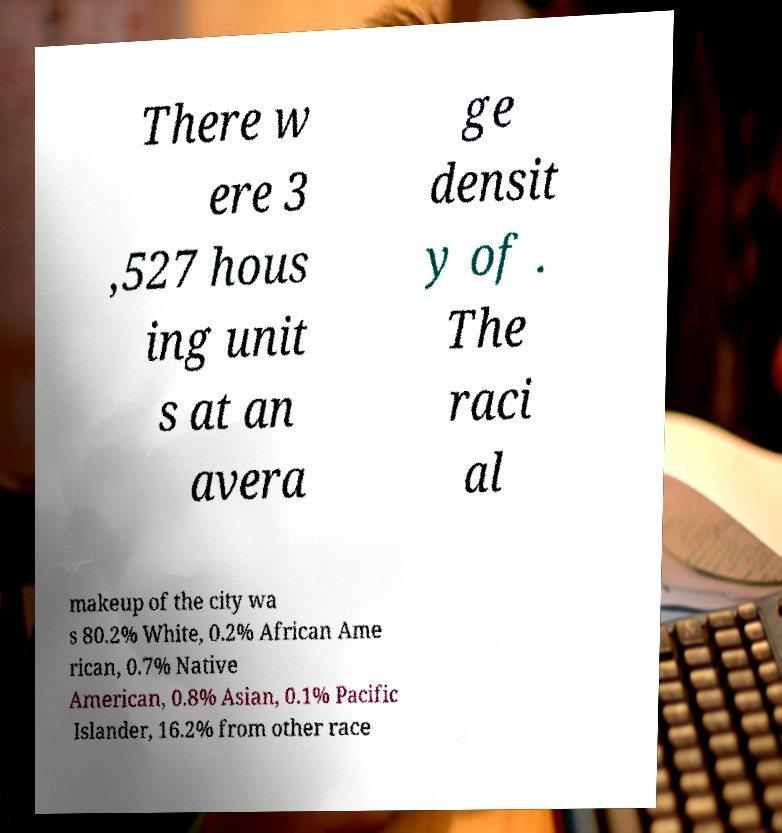Can you accurately transcribe the text from the provided image for me? There w ere 3 ,527 hous ing unit s at an avera ge densit y of . The raci al makeup of the city wa s 80.2% White, 0.2% African Ame rican, 0.7% Native American, 0.8% Asian, 0.1% Pacific Islander, 16.2% from other race 